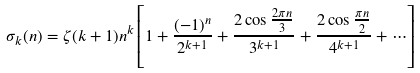<formula> <loc_0><loc_0><loc_500><loc_500>\sigma _ { k } ( n ) = \zeta ( k + 1 ) n ^ { k } \left [ 1 + { \frac { ( - 1 ) ^ { n } } { 2 ^ { k + 1 } } } + { \frac { 2 \cos { \frac { 2 \pi n } { 3 } } } { 3 ^ { k + 1 } } } + { \frac { 2 \cos { \frac { \pi n } { 2 } } } { 4 ^ { k + 1 } } } + \cdots \right ]</formula> 